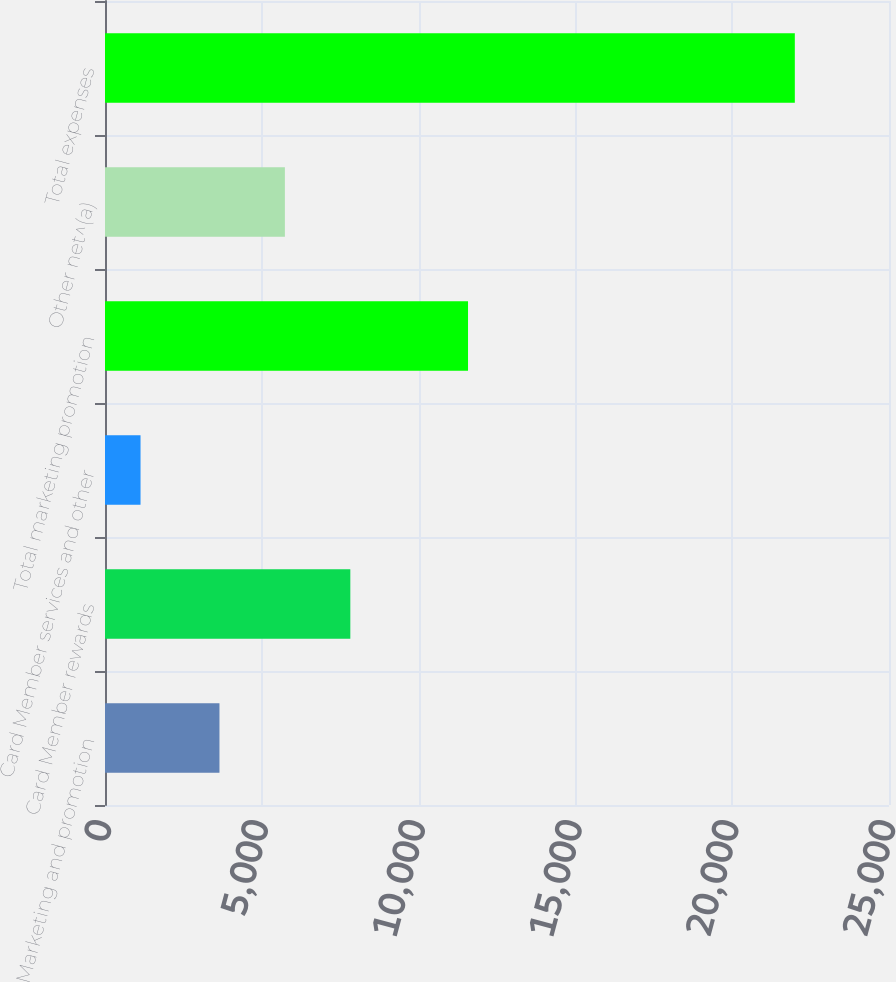<chart> <loc_0><loc_0><loc_500><loc_500><bar_chart><fcel>Marketing and promotion<fcel>Card Member rewards<fcel>Card Member services and other<fcel>Total marketing promotion<fcel>Other net^(a)<fcel>Total expenses<nl><fcel>3650<fcel>7822.8<fcel>1133<fcel>11576<fcel>5736.4<fcel>21997<nl></chart> 